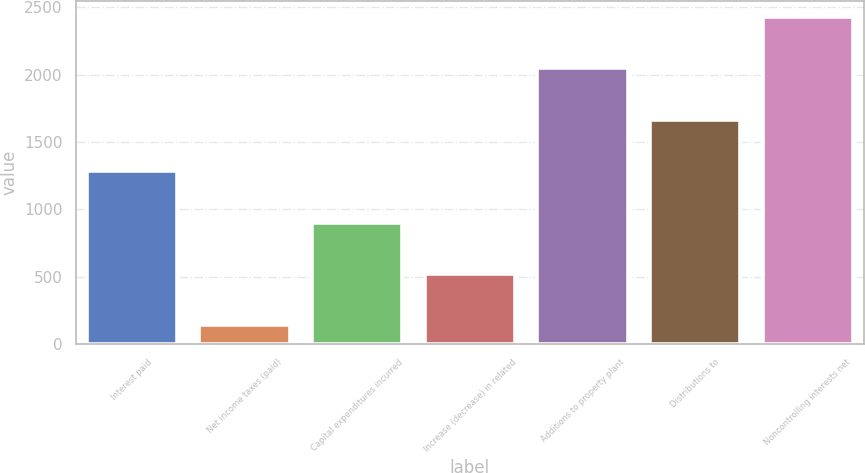Convert chart. <chart><loc_0><loc_0><loc_500><loc_500><bar_chart><fcel>Interest paid<fcel>Net income taxes (paid)<fcel>Capital expenditures incurred<fcel>Increase (decrease) in related<fcel>Additions to property plant<fcel>Distributions to<fcel>Noncontrolling interests net<nl><fcel>1283.6<fcel>140<fcel>902.4<fcel>521.2<fcel>2046<fcel>1664.8<fcel>2427.2<nl></chart> 